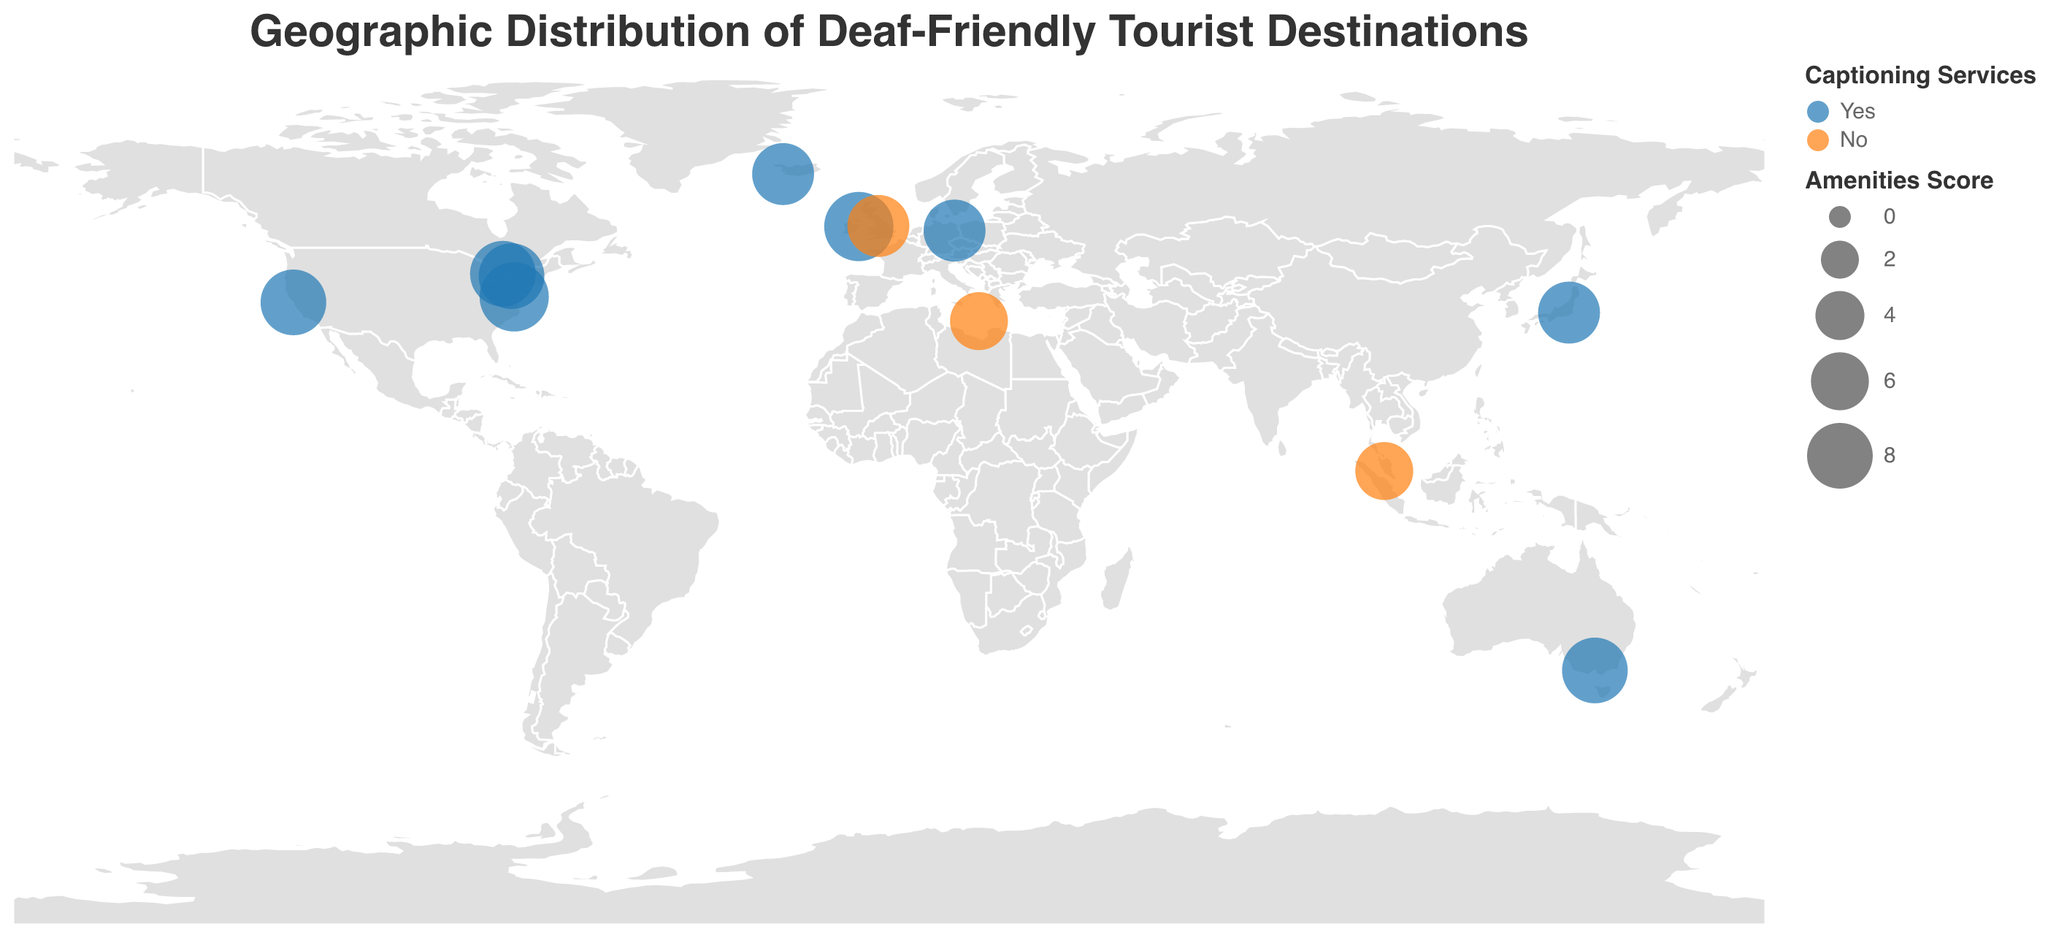What is the title of the geographic plot? The title of the plot is the text that appears at the top, which describes what the plot is about. By looking at the top of the figure, you can see the title "Geographic Distribution of Deaf-Friendly Tourist Destinations".
Answer: Geographic Distribution of Deaf-Friendly Tourist Destinations How many destinations provide both sign language tours and captioning services? To answer this question, look for dots on the plot that match the color for "Yes" under Captioning Services. Count the data points with this color that are present on the map.
Answer: 9 Which destination has the highest amenities score, and where is it located on the map? The data point with the largest circle represents the highest amenities score. By identifying the largest circle on the geographic plot, you can trace it back to its location and destination name. The largest circles on the map correspond to "Gallaudet University (Washington D.C.)" and "Deaf Village Ireland (Dublin)", both with an amenities score of 9.
Answer: Gallaudet University (Washington D.C.) and Deaf Village Ireland (Dublin) Which destinations do not provide captioning services? The data points indicating "No" for captioning services will be in a specific color (orange in this case). Identify these points on the plot and read the destination names associated with them.
Answer: Kuala Lumpur Deaf Club, Deaf Institute (Manchester), Cape Town Deaf Community Which destination is furthest west on the map? Look for the leftmost data point on the geographic plot. The leftmost point on the map represents the westernmost destination. The westernmost destination is "Deafopia (San Francisco)".
Answer: Deafopia (San Francisco) Among the destinations providing captioning services, what is the average amenities score? Identify the destinations that provide captioning services ("Yes") and note their amenities scores. Add these scores and divide by the number of such destinations to find the average. The scores are 9, 8, 9, 7, 8, 7, 7, 8. Calculation: (9 + 8 + 9 + 7 + 8 + 7 + 7 + 8) / 8 = 63 / 8 = 7.875.
Answer: 7.875 Which destination is closest to the equator? The equator has a latitude of 0. The destination with the latitude value closest to 0 is the closest to the equator. Among all points, "Kuala Lumpur Deaf Club" with a latitude of 3.1390 is the closest to the equator.
Answer: Kuala Lumpur Deaf Club How do "Gallaudet University (Washington D.C.)" and "Berlin Deaf History Museum" compare in terms of amenities score? Find the two destinations on the map and compare the sizes of their circles, which represent their amenities scores. "Gallaudet University (Washington D.C.)" has an amenities score of 9, whereas "Berlin Deaf History Museum" has a score of 7. Thus, Gallaudet University has a higher score.
Answer: Gallaudet University (Washington D.C.) has a higher amenities score than Berlin Deaf History Museum 